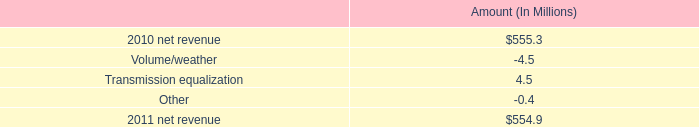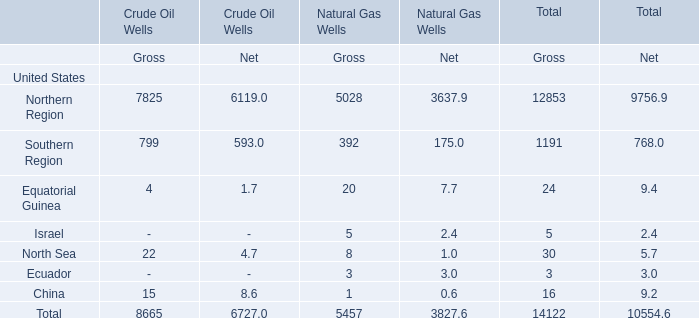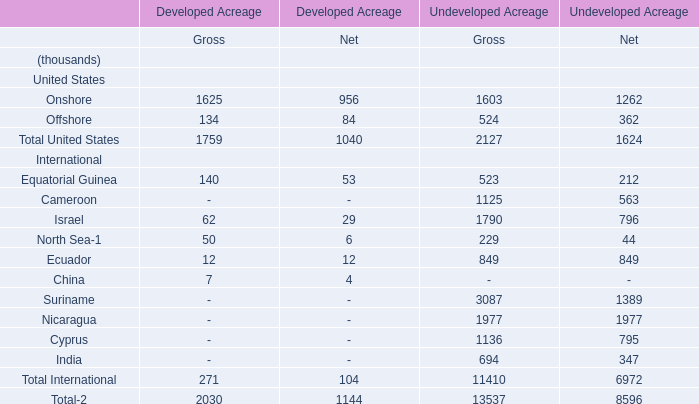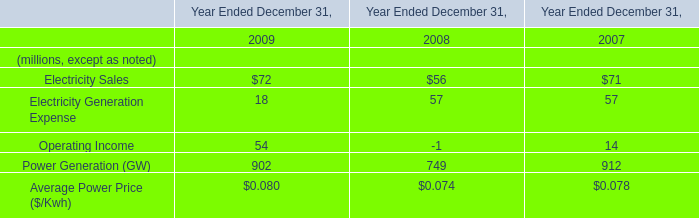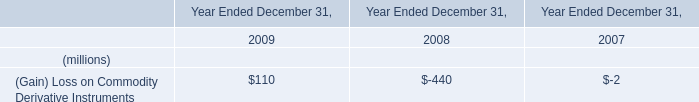What's the sum of Northern Region of Natural Gas Wells Gross, and Suriname International of Undeveloped Acreage Net ? 
Computations: (5028.0 + 1389.0)
Answer: 6417.0. 